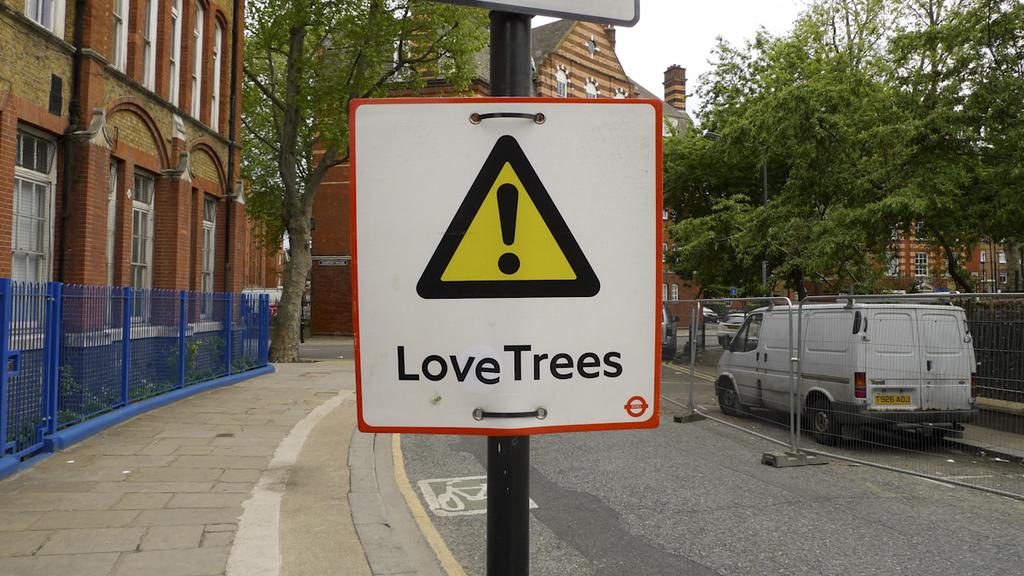What is written on the sign?
Provide a succinct answer. Love trees. This road landmarrk?
Provide a short and direct response. Not a question. 